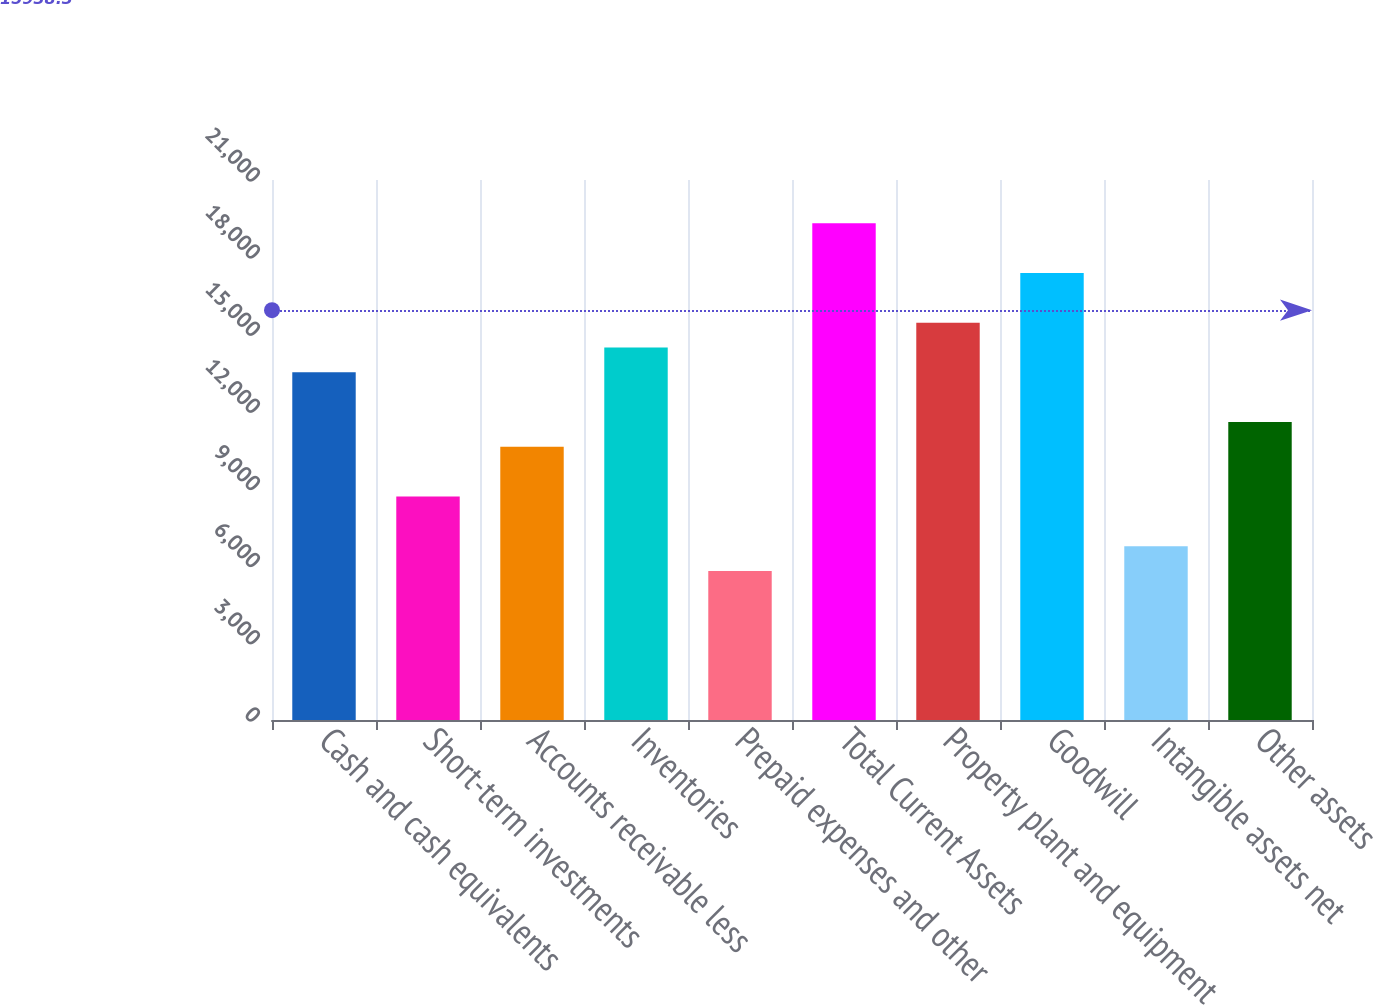<chart> <loc_0><loc_0><loc_500><loc_500><bar_chart><fcel>Cash and cash equivalents<fcel>Short-term investments<fcel>Accounts receivable less<fcel>Inventories<fcel>Prepaid expenses and other<fcel>Total Current Assets<fcel>Property plant and equipment<fcel>Goodwill<fcel>Intangible assets net<fcel>Other assets<nl><fcel>13520.5<fcel>8692.38<fcel>10623.6<fcel>14486.1<fcel>5795.52<fcel>19314.2<fcel>15451.7<fcel>17383<fcel>6761.14<fcel>11589.2<nl></chart> 